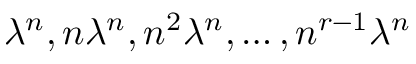<formula> <loc_0><loc_0><loc_500><loc_500>\lambda ^ { n } , n \lambda ^ { n } , n ^ { 2 } \lambda ^ { n } , \dots , n ^ { r - 1 } \lambda ^ { n }</formula> 